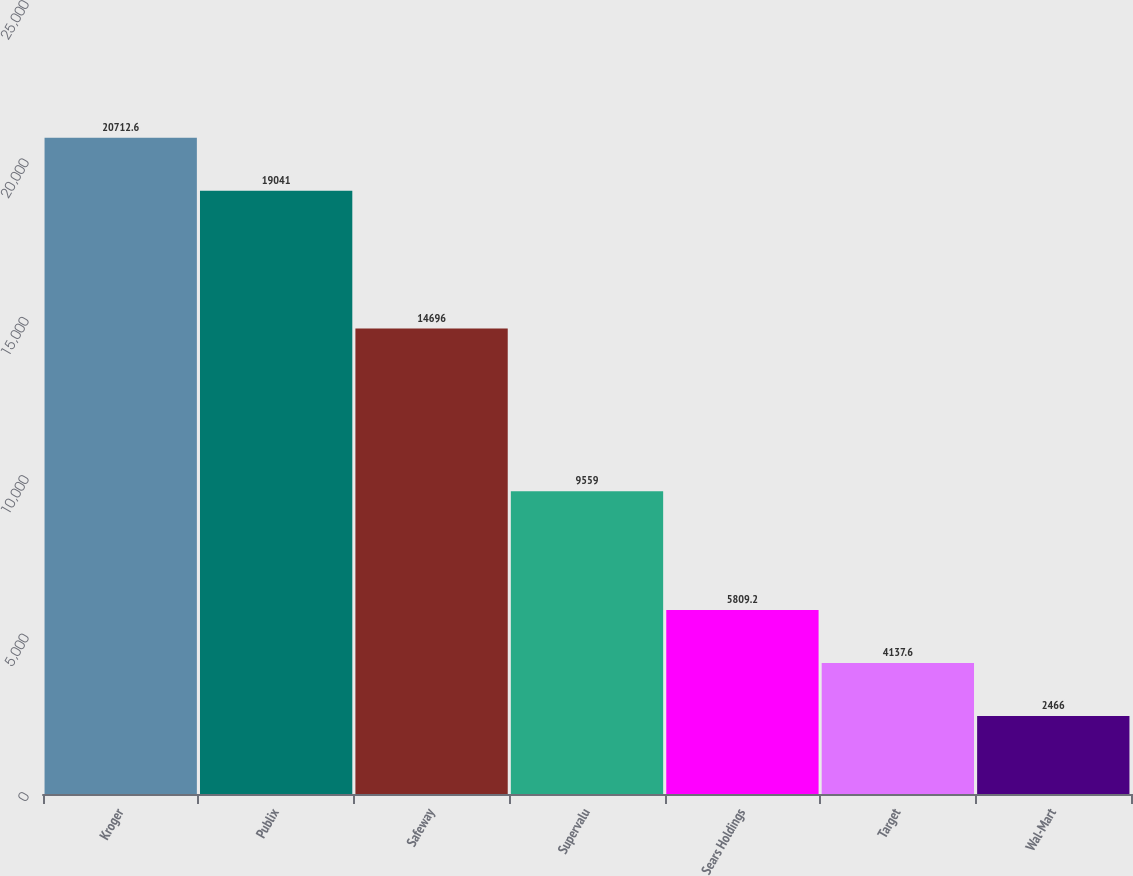Convert chart. <chart><loc_0><loc_0><loc_500><loc_500><bar_chart><fcel>Kroger<fcel>Publix<fcel>Safeway<fcel>Supervalu<fcel>Sears Holdings<fcel>Target<fcel>Wal-Mart<nl><fcel>20712.6<fcel>19041<fcel>14696<fcel>9559<fcel>5809.2<fcel>4137.6<fcel>2466<nl></chart> 